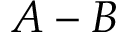Convert formula to latex. <formula><loc_0><loc_0><loc_500><loc_500>A - B</formula> 